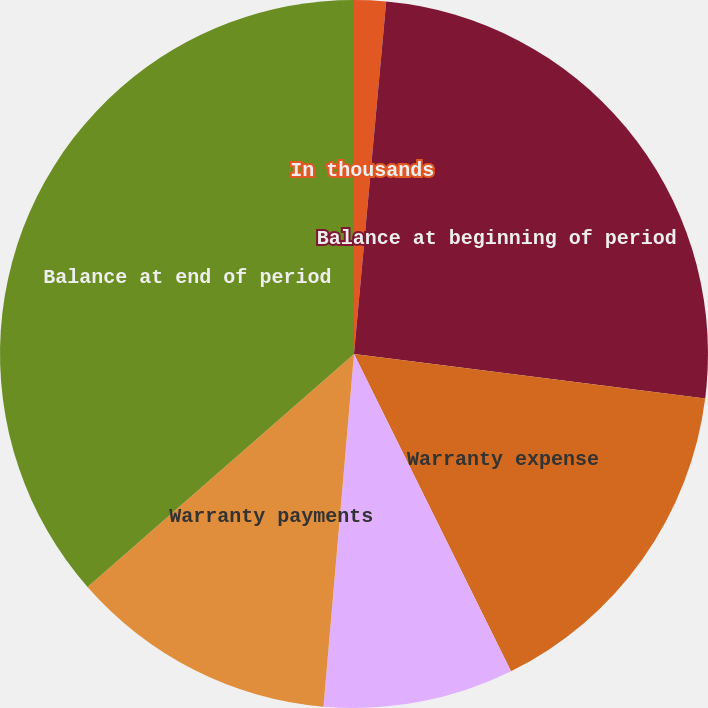Convert chart to OTSL. <chart><loc_0><loc_0><loc_500><loc_500><pie_chart><fcel>In thousands<fcel>Balance at beginning of period<fcel>Warranty expense<fcel>Acquisitions<fcel>Warranty payments<fcel>Balance at end of period<nl><fcel>1.45%<fcel>25.56%<fcel>15.68%<fcel>8.69%<fcel>12.19%<fcel>36.44%<nl></chart> 